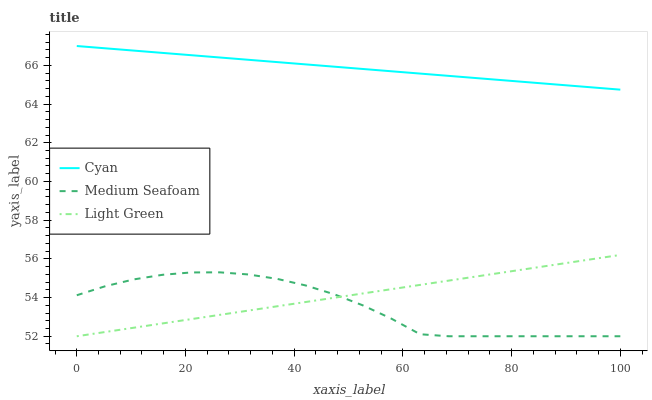Does Medium Seafoam have the minimum area under the curve?
Answer yes or no. Yes. Does Cyan have the maximum area under the curve?
Answer yes or no. Yes. Does Light Green have the minimum area under the curve?
Answer yes or no. No. Does Light Green have the maximum area under the curve?
Answer yes or no. No. Is Light Green the smoothest?
Answer yes or no. Yes. Is Medium Seafoam the roughest?
Answer yes or no. Yes. Is Medium Seafoam the smoothest?
Answer yes or no. No. Is Light Green the roughest?
Answer yes or no. No. Does Medium Seafoam have the lowest value?
Answer yes or no. Yes. Does Cyan have the highest value?
Answer yes or no. Yes. Does Light Green have the highest value?
Answer yes or no. No. Is Light Green less than Cyan?
Answer yes or no. Yes. Is Cyan greater than Light Green?
Answer yes or no. Yes. Does Medium Seafoam intersect Light Green?
Answer yes or no. Yes. Is Medium Seafoam less than Light Green?
Answer yes or no. No. Is Medium Seafoam greater than Light Green?
Answer yes or no. No. Does Light Green intersect Cyan?
Answer yes or no. No. 